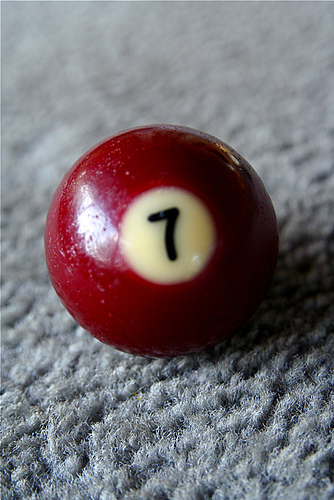<image>
Is there a pool ball above the carpet? Yes. The pool ball is positioned above the carpet in the vertical space, higher up in the scene. 